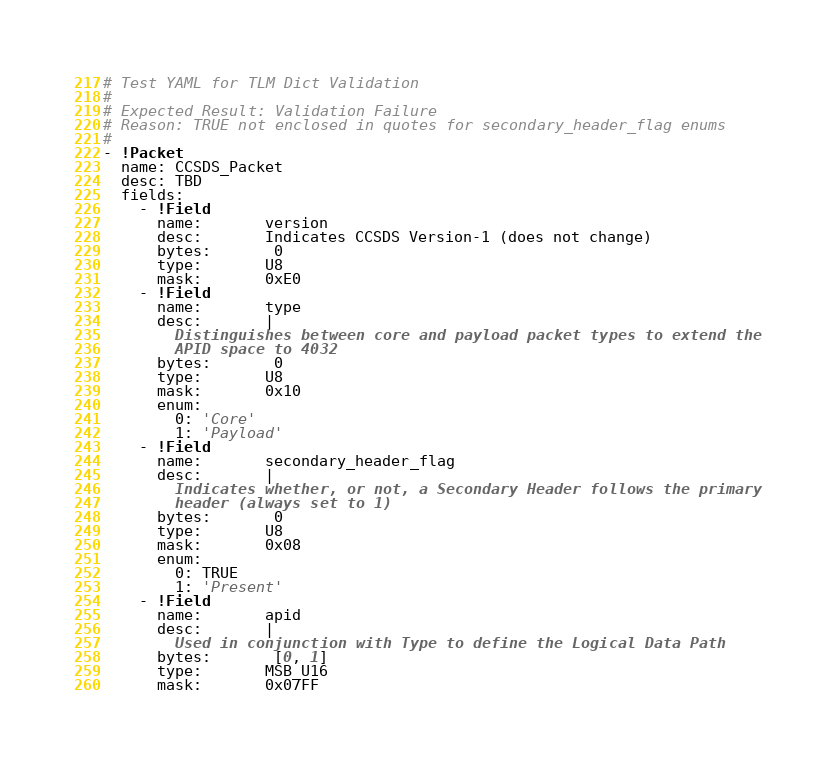Convert code to text. <code><loc_0><loc_0><loc_500><loc_500><_YAML_># Test YAML for TLM Dict Validation
#
# Expected Result: Validation Failure
# Reason: TRUE not enclosed in quotes for secondary_header_flag enums
#
- !Packet
  name: CCSDS_Packet
  desc: TBD
  fields:
    - !Field
      name:       version
      desc:       Indicates CCSDS Version-1 (does not change)
      bytes:       0
      type:       U8
      mask:       0xE0
    - !Field
      name:       type
      desc:       |
        Distinguishes between core and payload packet types to extend the
        APID space to 4032
      bytes:       0
      type:       U8
      mask:       0x10
      enum:
        0: 'Core'
        1: 'Payload'
    - !Field
      name:       secondary_header_flag
      desc:       |
        Indicates whether, or not, a Secondary Header follows the primary
        header (always set to 1)
      bytes:       0
      type:       U8
      mask:       0x08
      enum:
        0: TRUE
        1: 'Present'
    - !Field
      name:       apid
      desc:       |
        Used in conjunction with Type to define the Logical Data Path
      bytes:       [0, 1]
      type:       MSB_U16
      mask:       0x07FF
</code> 